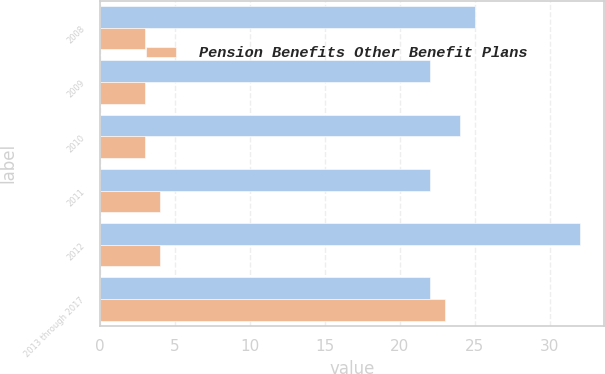Convert chart. <chart><loc_0><loc_0><loc_500><loc_500><stacked_bar_chart><ecel><fcel>2008<fcel>2009<fcel>2010<fcel>2011<fcel>2012<fcel>2013 through 2017<nl><fcel>nan<fcel>25<fcel>22<fcel>24<fcel>22<fcel>32<fcel>22<nl><fcel>Pension Benefits Other Benefit Plans<fcel>3<fcel>3<fcel>3<fcel>4<fcel>4<fcel>23<nl></chart> 